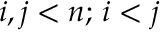Convert formula to latex. <formula><loc_0><loc_0><loc_500><loc_500>i , j < n ; \, i < j</formula> 